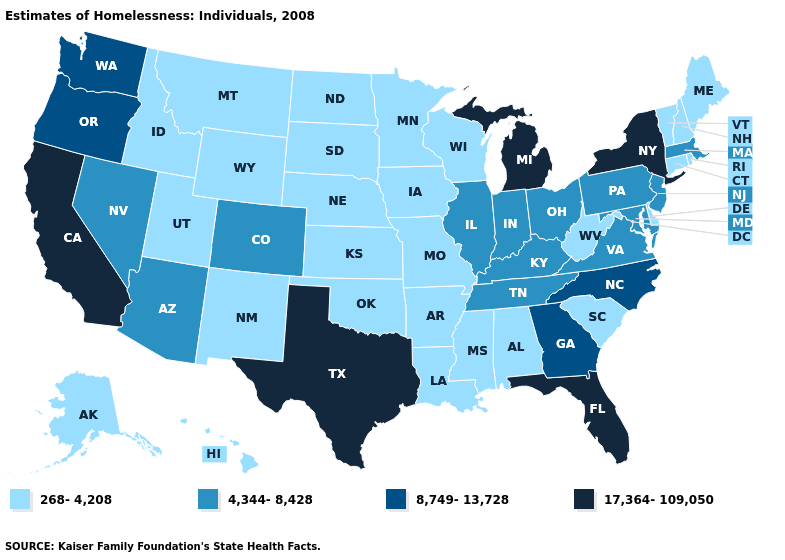What is the highest value in the MidWest ?
Be succinct. 17,364-109,050. Does New York have the same value as California?
Quick response, please. Yes. Does Colorado have the lowest value in the West?
Quick response, please. No. What is the value of Oregon?
Be succinct. 8,749-13,728. Does Colorado have the highest value in the USA?
Short answer required. No. Which states have the highest value in the USA?
Answer briefly. California, Florida, Michigan, New York, Texas. Among the states that border Kansas , which have the lowest value?
Concise answer only. Missouri, Nebraska, Oklahoma. Which states have the lowest value in the West?
Concise answer only. Alaska, Hawaii, Idaho, Montana, New Mexico, Utah, Wyoming. What is the highest value in the USA?
Answer briefly. 17,364-109,050. Does the first symbol in the legend represent the smallest category?
Short answer required. Yes. What is the lowest value in states that border Montana?
Short answer required. 268-4,208. What is the lowest value in states that border Iowa?
Be succinct. 268-4,208. What is the lowest value in states that border Missouri?
Write a very short answer. 268-4,208. Does the map have missing data?
Answer briefly. No. Name the states that have a value in the range 17,364-109,050?
Give a very brief answer. California, Florida, Michigan, New York, Texas. 